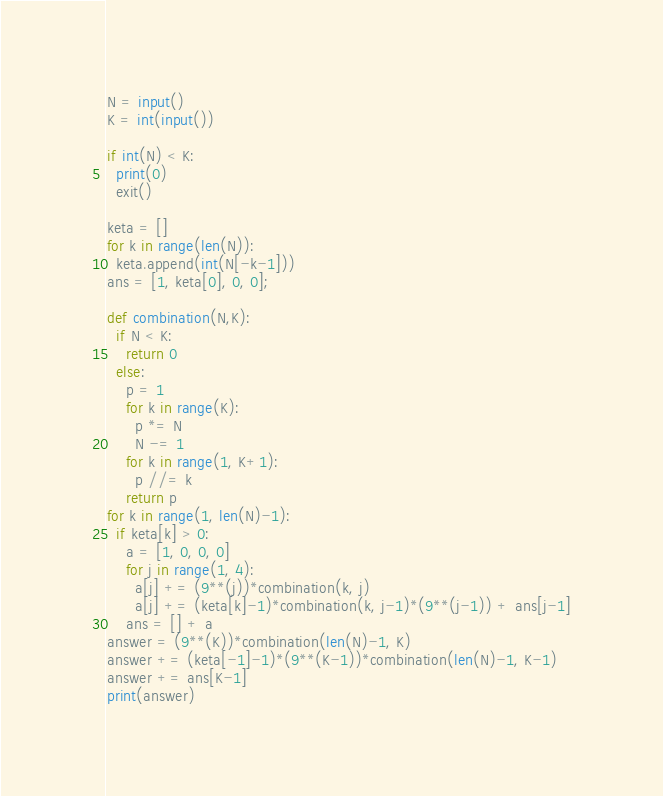<code> <loc_0><loc_0><loc_500><loc_500><_Python_>N = input()
K = int(input())

if int(N) < K:
  print(0)
  exit()

keta = []
for k in range(len(N)):
  keta.append(int(N[-k-1]))
ans = [1, keta[0], 0, 0];

def combination(N,K):
  if N < K:
    return 0
  else:
    p = 1
    for k in range(K):
      p *= N
      N -= 1
    for k in range(1, K+1):
      p //= k
    return p
for k in range(1, len(N)-1):
  if keta[k] > 0:
    a = [1, 0, 0, 0]
    for j in range(1, 4):
      a[j] += (9**(j))*combination(k, j)
      a[j] += (keta[k]-1)*combination(k, j-1)*(9**(j-1)) + ans[j-1]
    ans = [] + a
answer = (9**(K))*combination(len(N)-1, K)
answer += (keta[-1]-1)*(9**(K-1))*combination(len(N)-1, K-1)
answer += ans[K-1]
print(answer)</code> 